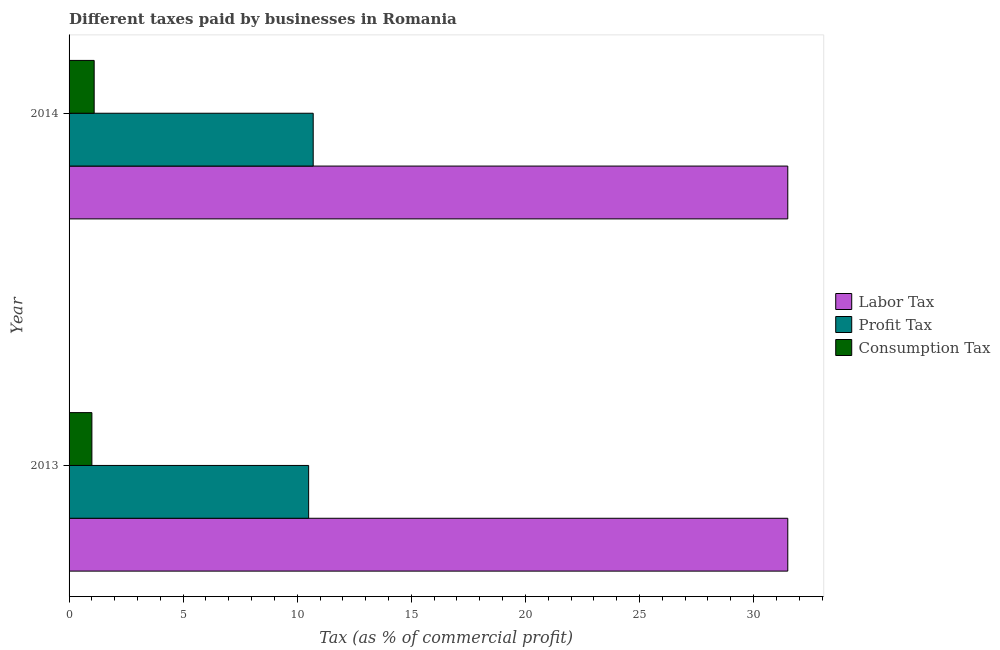How many different coloured bars are there?
Keep it short and to the point. 3. How many groups of bars are there?
Your answer should be very brief. 2. Are the number of bars per tick equal to the number of legend labels?
Your response must be concise. Yes. Are the number of bars on each tick of the Y-axis equal?
Give a very brief answer. Yes. How many bars are there on the 2nd tick from the top?
Your response must be concise. 3. How many bars are there on the 1st tick from the bottom?
Give a very brief answer. 3. What is the percentage of consumption tax in 2013?
Offer a terse response. 1. Across all years, what is the maximum percentage of labor tax?
Offer a terse response. 31.5. In which year was the percentage of consumption tax minimum?
Offer a very short reply. 2013. What is the total percentage of profit tax in the graph?
Your answer should be very brief. 21.2. What is the difference between the percentage of consumption tax in 2013 and the percentage of profit tax in 2014?
Provide a short and direct response. -9.7. What is the average percentage of profit tax per year?
Provide a succinct answer. 10.6. In the year 2014, what is the difference between the percentage of profit tax and percentage of consumption tax?
Keep it short and to the point. 9.6. What is the ratio of the percentage of profit tax in 2013 to that in 2014?
Your response must be concise. 0.98. Is the percentage of labor tax in 2013 less than that in 2014?
Keep it short and to the point. No. Is the difference between the percentage of labor tax in 2013 and 2014 greater than the difference between the percentage of consumption tax in 2013 and 2014?
Your answer should be very brief. Yes. In how many years, is the percentage of profit tax greater than the average percentage of profit tax taken over all years?
Give a very brief answer. 1. What does the 2nd bar from the top in 2014 represents?
Your response must be concise. Profit Tax. What does the 1st bar from the bottom in 2014 represents?
Offer a terse response. Labor Tax. Is it the case that in every year, the sum of the percentage of labor tax and percentage of profit tax is greater than the percentage of consumption tax?
Provide a short and direct response. Yes. How many bars are there?
Provide a short and direct response. 6. How many years are there in the graph?
Your answer should be very brief. 2. What is the difference between two consecutive major ticks on the X-axis?
Keep it short and to the point. 5. How many legend labels are there?
Ensure brevity in your answer.  3. How are the legend labels stacked?
Your response must be concise. Vertical. What is the title of the graph?
Your answer should be compact. Different taxes paid by businesses in Romania. What is the label or title of the X-axis?
Your answer should be very brief. Tax (as % of commercial profit). What is the Tax (as % of commercial profit) in Labor Tax in 2013?
Your response must be concise. 31.5. What is the Tax (as % of commercial profit) in Labor Tax in 2014?
Give a very brief answer. 31.5. Across all years, what is the maximum Tax (as % of commercial profit) of Labor Tax?
Give a very brief answer. 31.5. Across all years, what is the maximum Tax (as % of commercial profit) in Profit Tax?
Ensure brevity in your answer.  10.7. Across all years, what is the maximum Tax (as % of commercial profit) in Consumption Tax?
Provide a succinct answer. 1.1. Across all years, what is the minimum Tax (as % of commercial profit) of Labor Tax?
Offer a terse response. 31.5. Across all years, what is the minimum Tax (as % of commercial profit) in Profit Tax?
Offer a very short reply. 10.5. Across all years, what is the minimum Tax (as % of commercial profit) of Consumption Tax?
Ensure brevity in your answer.  1. What is the total Tax (as % of commercial profit) in Labor Tax in the graph?
Your response must be concise. 63. What is the total Tax (as % of commercial profit) in Profit Tax in the graph?
Provide a short and direct response. 21.2. What is the difference between the Tax (as % of commercial profit) of Labor Tax in 2013 and that in 2014?
Make the answer very short. 0. What is the difference between the Tax (as % of commercial profit) in Consumption Tax in 2013 and that in 2014?
Offer a very short reply. -0.1. What is the difference between the Tax (as % of commercial profit) in Labor Tax in 2013 and the Tax (as % of commercial profit) in Profit Tax in 2014?
Your response must be concise. 20.8. What is the difference between the Tax (as % of commercial profit) of Labor Tax in 2013 and the Tax (as % of commercial profit) of Consumption Tax in 2014?
Ensure brevity in your answer.  30.4. What is the difference between the Tax (as % of commercial profit) of Profit Tax in 2013 and the Tax (as % of commercial profit) of Consumption Tax in 2014?
Ensure brevity in your answer.  9.4. What is the average Tax (as % of commercial profit) in Labor Tax per year?
Give a very brief answer. 31.5. What is the average Tax (as % of commercial profit) of Profit Tax per year?
Your answer should be compact. 10.6. In the year 2013, what is the difference between the Tax (as % of commercial profit) in Labor Tax and Tax (as % of commercial profit) in Profit Tax?
Your response must be concise. 21. In the year 2013, what is the difference between the Tax (as % of commercial profit) in Labor Tax and Tax (as % of commercial profit) in Consumption Tax?
Ensure brevity in your answer.  30.5. In the year 2013, what is the difference between the Tax (as % of commercial profit) of Profit Tax and Tax (as % of commercial profit) of Consumption Tax?
Your answer should be compact. 9.5. In the year 2014, what is the difference between the Tax (as % of commercial profit) in Labor Tax and Tax (as % of commercial profit) in Profit Tax?
Offer a very short reply. 20.8. In the year 2014, what is the difference between the Tax (as % of commercial profit) of Labor Tax and Tax (as % of commercial profit) of Consumption Tax?
Offer a very short reply. 30.4. What is the ratio of the Tax (as % of commercial profit) of Profit Tax in 2013 to that in 2014?
Provide a short and direct response. 0.98. What is the ratio of the Tax (as % of commercial profit) of Consumption Tax in 2013 to that in 2014?
Give a very brief answer. 0.91. What is the difference between the highest and the second highest Tax (as % of commercial profit) in Profit Tax?
Keep it short and to the point. 0.2. What is the difference between the highest and the second highest Tax (as % of commercial profit) in Consumption Tax?
Offer a very short reply. 0.1. What is the difference between the highest and the lowest Tax (as % of commercial profit) of Labor Tax?
Give a very brief answer. 0. What is the difference between the highest and the lowest Tax (as % of commercial profit) of Consumption Tax?
Give a very brief answer. 0.1. 